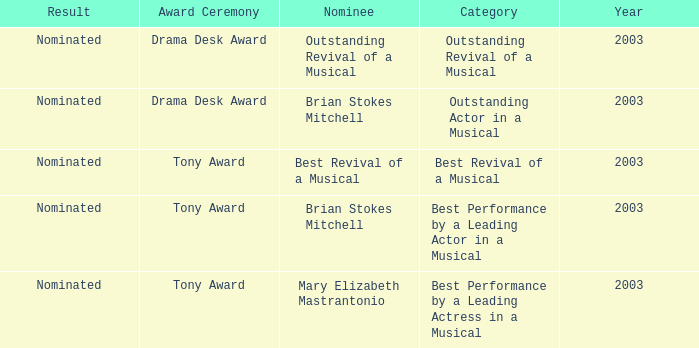Help me parse the entirety of this table. {'header': ['Result', 'Award Ceremony', 'Nominee', 'Category', 'Year'], 'rows': [['Nominated', 'Drama Desk Award', 'Outstanding Revival of a Musical', 'Outstanding Revival of a Musical', '2003'], ['Nominated', 'Drama Desk Award', 'Brian Stokes Mitchell', 'Outstanding Actor in a Musical', '2003'], ['Nominated', 'Tony Award', 'Best Revival of a Musical', 'Best Revival of a Musical', '2003'], ['Nominated', 'Tony Award', 'Brian Stokes Mitchell', 'Best Performance by a Leading Actor in a Musical', '2003'], ['Nominated', 'Tony Award', 'Mary Elizabeth Mastrantonio', 'Best Performance by a Leading Actress in a Musical', '2003']]} What was the result for the nomination of Best Revival of a Musical? Nominated. 